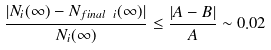<formula> <loc_0><loc_0><loc_500><loc_500>\frac { | N _ { i } ( \infty ) - N _ { f i n a l \ i } ( \infty ) | } { N _ { i } ( \infty ) } \leq \frac { | A - B | } { A } \sim 0 . 0 2</formula> 